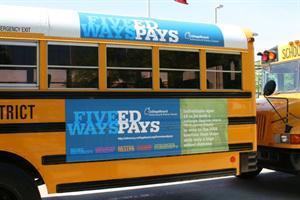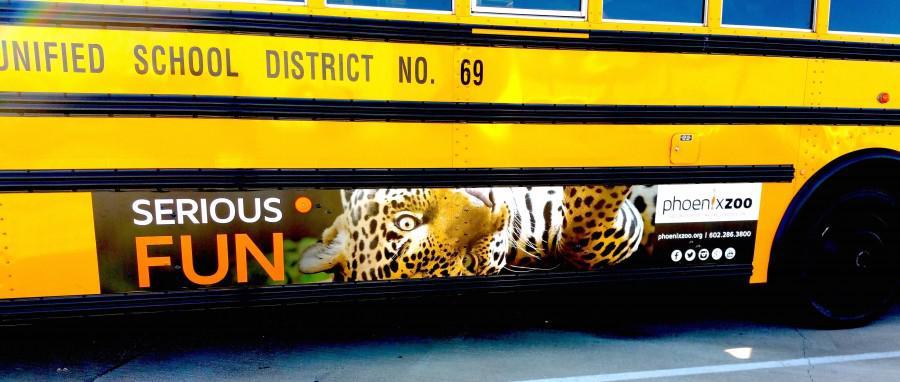The first image is the image on the left, the second image is the image on the right. Evaluate the accuracy of this statement regarding the images: "There is a bus with at least one shild in the advertizing on the side of the bus". Is it true? Answer yes or no. No. The first image is the image on the left, the second image is the image on the right. Given the left and right images, does the statement "All images show a sign on the side of a school bus that contains at least one human face, and at least one image features a school bus sign with multiple kids faces on it." hold true? Answer yes or no. No. 